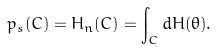Convert formula to latex. <formula><loc_0><loc_0><loc_500><loc_500>p _ { s } ( C ) = H _ { n } ( C ) = \int _ { C } d H ( \theta ) .</formula> 